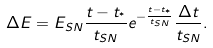<formula> <loc_0><loc_0><loc_500><loc_500>\Delta E = E _ { S N } \frac { t - t _ { ^ { * } } } { t _ { S N } } e ^ { - \frac { t - t _ { ^ { * } } } { t _ { S N } } } \frac { \Delta t } { t _ { S N } } .</formula> 